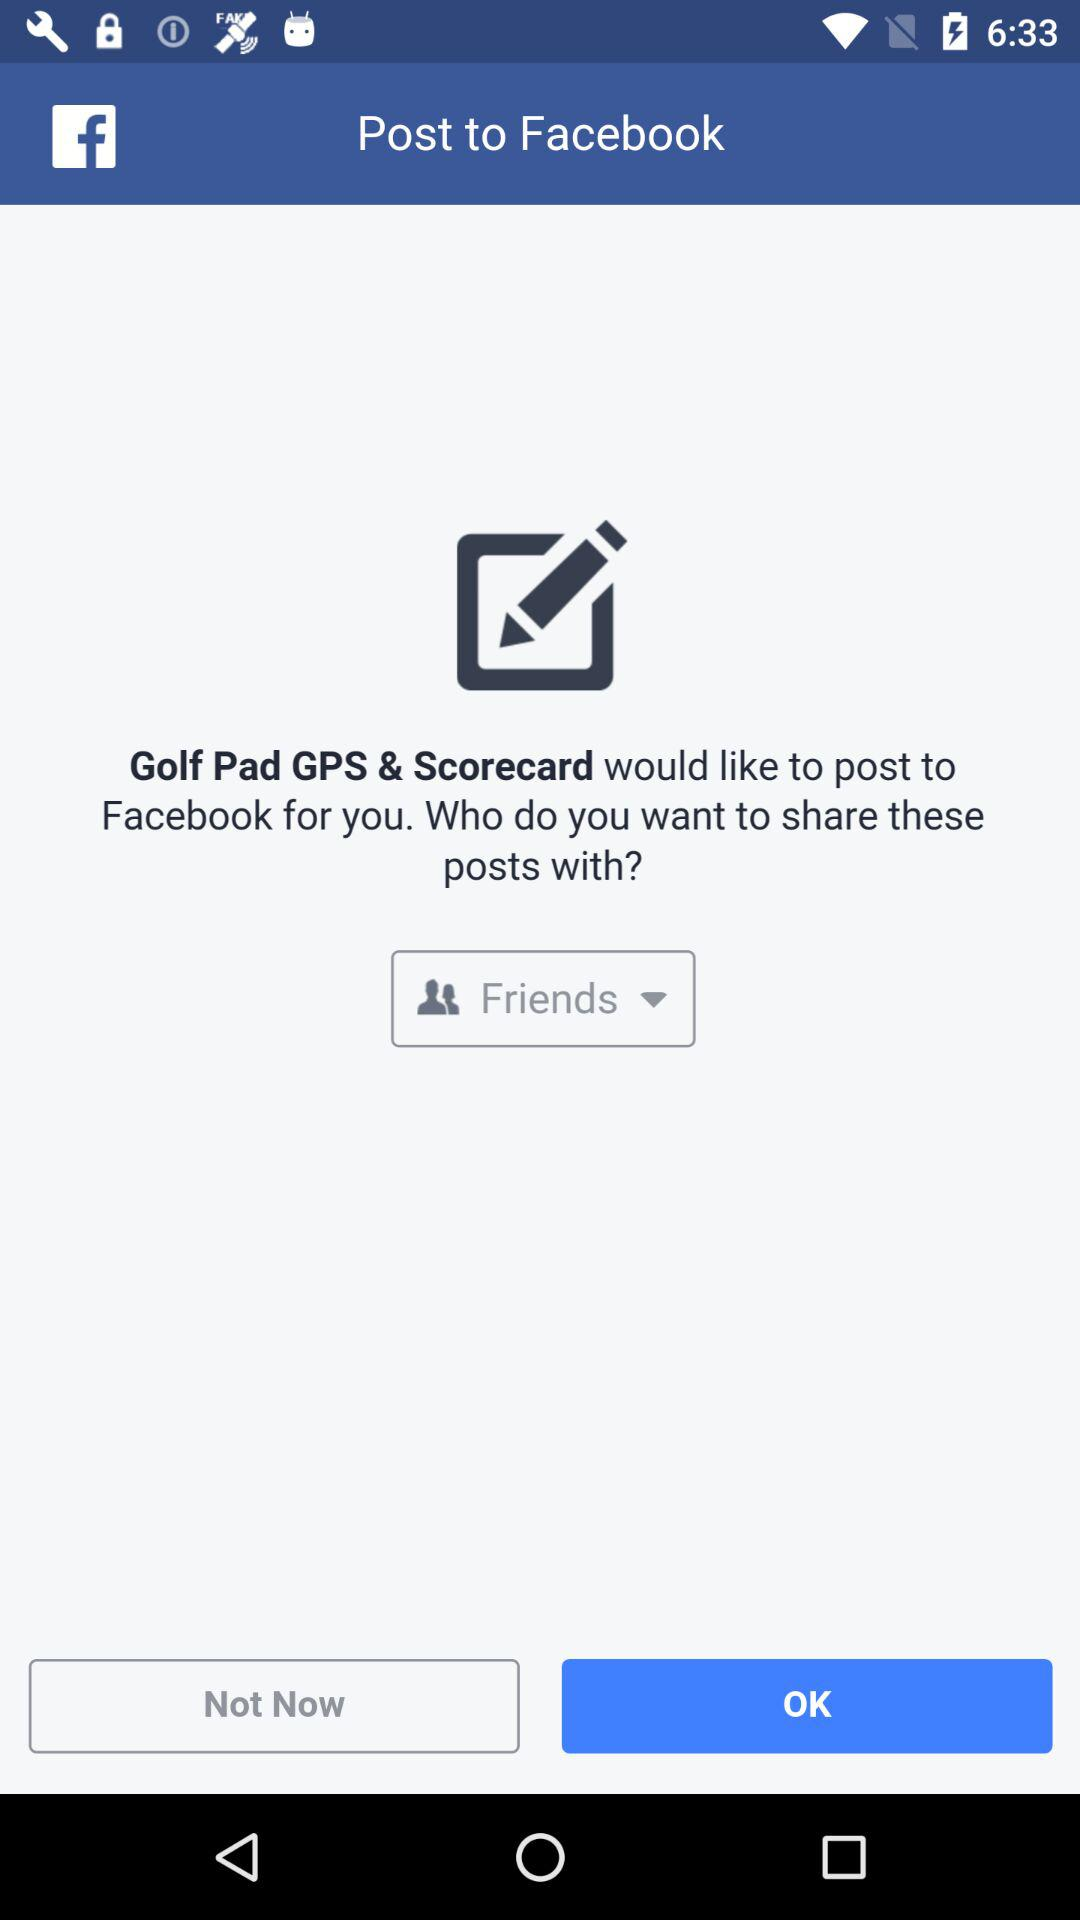Whom can the post be shared with? The post can be shared with "Friends". 